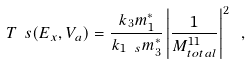Convert formula to latex. <formula><loc_0><loc_0><loc_500><loc_500>T _ { \ } s ( E _ { x } , V _ { a } ) = \frac { k _ { 3 } m _ { 1 } ^ { * } } { k _ { 1 \ s } m _ { 3 } ^ { * } } \left | \frac { 1 } { M _ { t o t a l } ^ { 1 1 } } \right | ^ { 2 } \ ,</formula> 